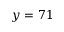<formula> <loc_0><loc_0><loc_500><loc_500>y = 7 1</formula> 